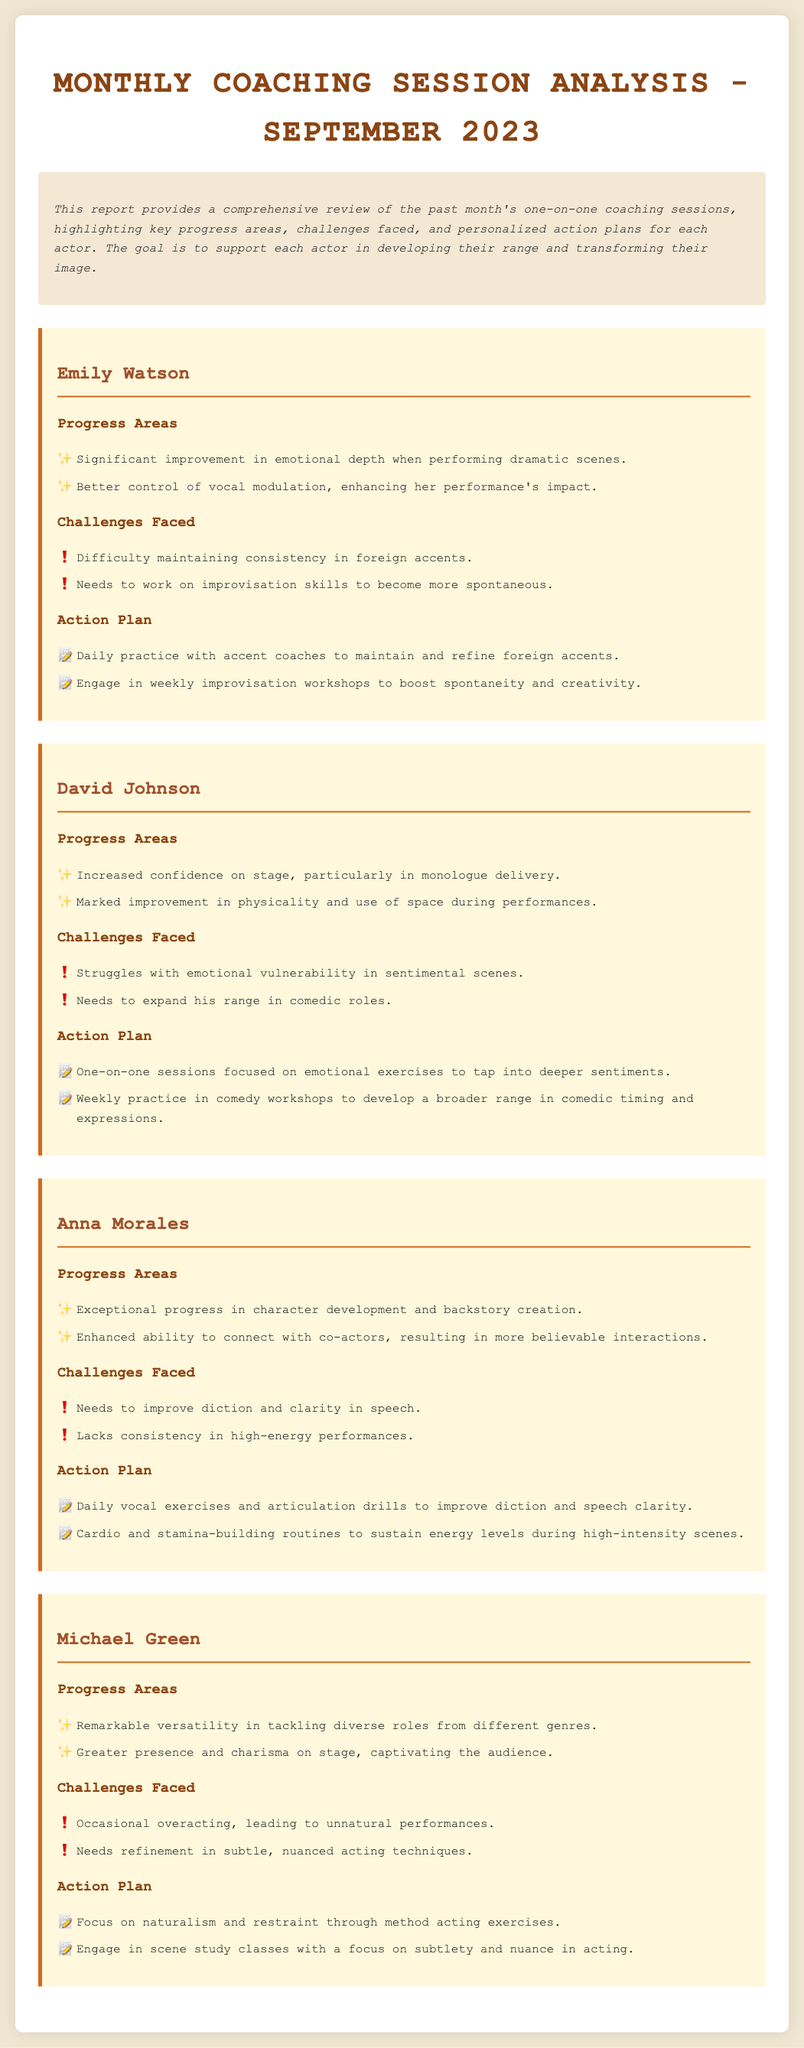What is the title of the document? The title of the document is prominently displayed at the top of the rendered page, identifying it as a monthly analysis report for a specific month.
Answer: Monthly Coaching Session Analysis - September 2023 Who is the first actor mentioned in the document? The first actor listed in the coaching sessions is presented as a section header in the document under the actor category.
Answer: Emily Watson How many progress areas are highlighted for David Johnson? The number of progress areas is indicated by the bullet points listed under his section, detailing his improvements.
Answer: 2 What is one challenge faced by Anna Morales? The challenges faced are clearly enumerated for each actor, providing insight into the specific limitations encountered during coaching.
Answer: Needs to improve diction and clarity in speech What type of workshops is Emily Watson advised to join? The suggested activities in the action plan section outline specific types of workshops or practice sessions for the actors to enhance their skills.
Answer: Weekly improvisation workshops How did Michael Green improve on stage? The improvement aspects are highlighted under each actor's progress areas, showcasing their development over the month.
Answer: Greater presence and charisma on stage What is one action plan recommendation for David Johnson? Each actor has personalized action plans that are specified in list format, indicating the intended steps for further development.
Answer: One-on-one sessions focused on emotional exercises What is the main goal of the coaching sessions? The main goal is articulated in the overview section, summarizing the overall purpose of the monthly analysis and coaching sessions.
Answer: To support each actor in developing their range and transforming their image 